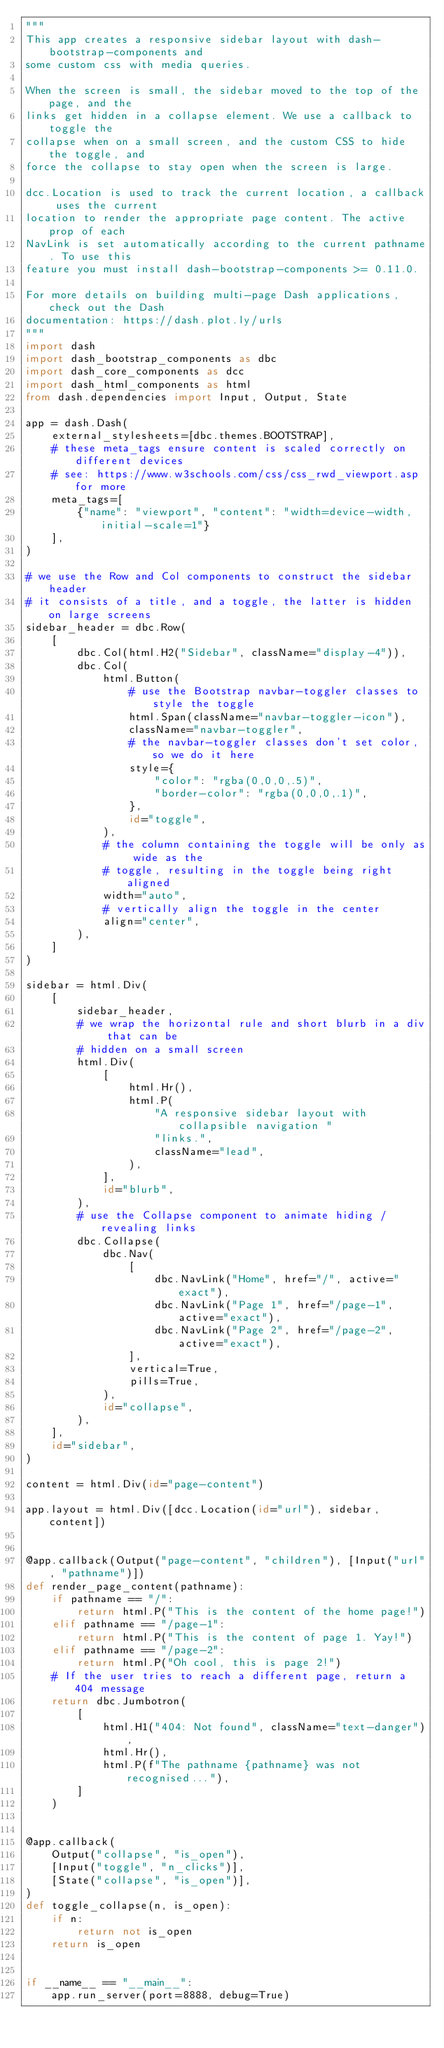<code> <loc_0><loc_0><loc_500><loc_500><_Python_>"""
This app creates a responsive sidebar layout with dash-bootstrap-components and
some custom css with media queries.

When the screen is small, the sidebar moved to the top of the page, and the
links get hidden in a collapse element. We use a callback to toggle the
collapse when on a small screen, and the custom CSS to hide the toggle, and
force the collapse to stay open when the screen is large.

dcc.Location is used to track the current location, a callback uses the current
location to render the appropriate page content. The active prop of each
NavLink is set automatically according to the current pathname. To use this
feature you must install dash-bootstrap-components >= 0.11.0.

For more details on building multi-page Dash applications, check out the Dash
documentation: https://dash.plot.ly/urls
"""
import dash
import dash_bootstrap_components as dbc
import dash_core_components as dcc
import dash_html_components as html
from dash.dependencies import Input, Output, State

app = dash.Dash(
    external_stylesheets=[dbc.themes.BOOTSTRAP],
    # these meta_tags ensure content is scaled correctly on different devices
    # see: https://www.w3schools.com/css/css_rwd_viewport.asp for more
    meta_tags=[
        {"name": "viewport", "content": "width=device-width, initial-scale=1"}
    ],
)

# we use the Row and Col components to construct the sidebar header
# it consists of a title, and a toggle, the latter is hidden on large screens
sidebar_header = dbc.Row(
    [
        dbc.Col(html.H2("Sidebar", className="display-4")),
        dbc.Col(
            html.Button(
                # use the Bootstrap navbar-toggler classes to style the toggle
                html.Span(className="navbar-toggler-icon"),
                className="navbar-toggler",
                # the navbar-toggler classes don't set color, so we do it here
                style={
                    "color": "rgba(0,0,0,.5)",
                    "border-color": "rgba(0,0,0,.1)",
                },
                id="toggle",
            ),
            # the column containing the toggle will be only as wide as the
            # toggle, resulting in the toggle being right aligned
            width="auto",
            # vertically align the toggle in the center
            align="center",
        ),
    ]
)

sidebar = html.Div(
    [
        sidebar_header,
        # we wrap the horizontal rule and short blurb in a div that can be
        # hidden on a small screen
        html.Div(
            [
                html.Hr(),
                html.P(
                    "A responsive sidebar layout with collapsible navigation "
                    "links.",
                    className="lead",
                ),
            ],
            id="blurb",
        ),
        # use the Collapse component to animate hiding / revealing links
        dbc.Collapse(
            dbc.Nav(
                [
                    dbc.NavLink("Home", href="/", active="exact"),
                    dbc.NavLink("Page 1", href="/page-1", active="exact"),
                    dbc.NavLink("Page 2", href="/page-2", active="exact"),
                ],
                vertical=True,
                pills=True,
            ),
            id="collapse",
        ),
    ],
    id="sidebar",
)

content = html.Div(id="page-content")

app.layout = html.Div([dcc.Location(id="url"), sidebar, content])


@app.callback(Output("page-content", "children"), [Input("url", "pathname")])
def render_page_content(pathname):
    if pathname == "/":
        return html.P("This is the content of the home page!")
    elif pathname == "/page-1":
        return html.P("This is the content of page 1. Yay!")
    elif pathname == "/page-2":
        return html.P("Oh cool, this is page 2!")
    # If the user tries to reach a different page, return a 404 message
    return dbc.Jumbotron(
        [
            html.H1("404: Not found", className="text-danger"),
            html.Hr(),
            html.P(f"The pathname {pathname} was not recognised..."),
        ]
    )


@app.callback(
    Output("collapse", "is_open"),
    [Input("toggle", "n_clicks")],
    [State("collapse", "is_open")],
)
def toggle_collapse(n, is_open):
    if n:
        return not is_open
    return is_open


if __name__ == "__main__":
    app.run_server(port=8888, debug=True)</code> 